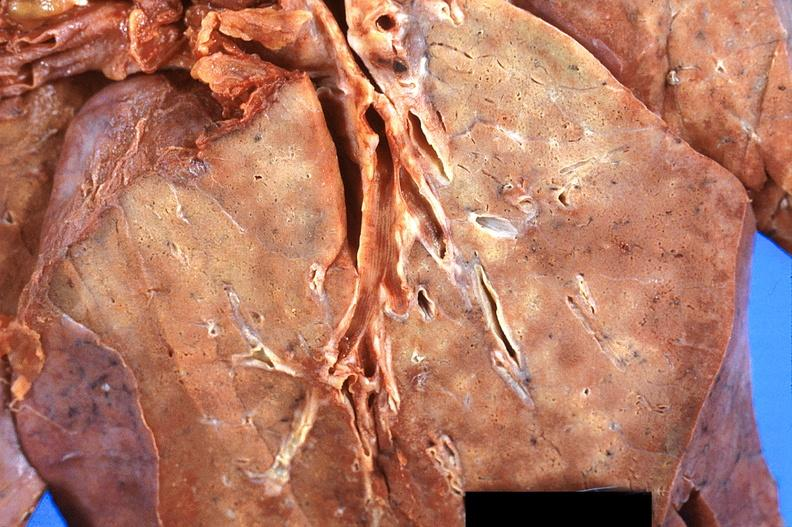what does this image show?
Answer the question using a single word or phrase. Lung 